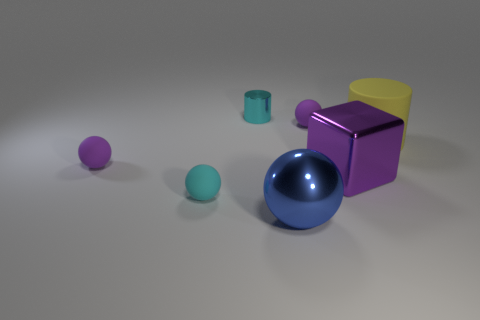There is a matte sphere that is the same color as the small shiny object; what size is it?
Provide a succinct answer. Small. Does the yellow rubber cylinder behind the blue sphere have the same size as the purple matte ball that is on the right side of the cyan cylinder?
Offer a terse response. No. What number of other things are there of the same color as the large metallic cube?
Provide a short and direct response. 2. Is the size of the metallic sphere the same as the cylinder that is on the left side of the big purple thing?
Provide a short and direct response. No. What size is the purple ball that is on the right side of the tiny purple matte ball on the left side of the shiny cylinder?
Offer a terse response. Small. There is a tiny metal thing that is the same shape as the large yellow thing; what is its color?
Make the answer very short. Cyan. Does the cyan sphere have the same size as the yellow rubber cylinder?
Give a very brief answer. No. Are there the same number of big blue objects behind the big purple shiny object and blue things?
Provide a short and direct response. No. Is there a big purple shiny cube that is on the right side of the big yellow rubber cylinder behind the big purple shiny object?
Make the answer very short. No. There is a cyan object that is in front of the tiny cyan object that is behind the small purple matte sphere that is right of the tiny cyan ball; how big is it?
Offer a terse response. Small. 